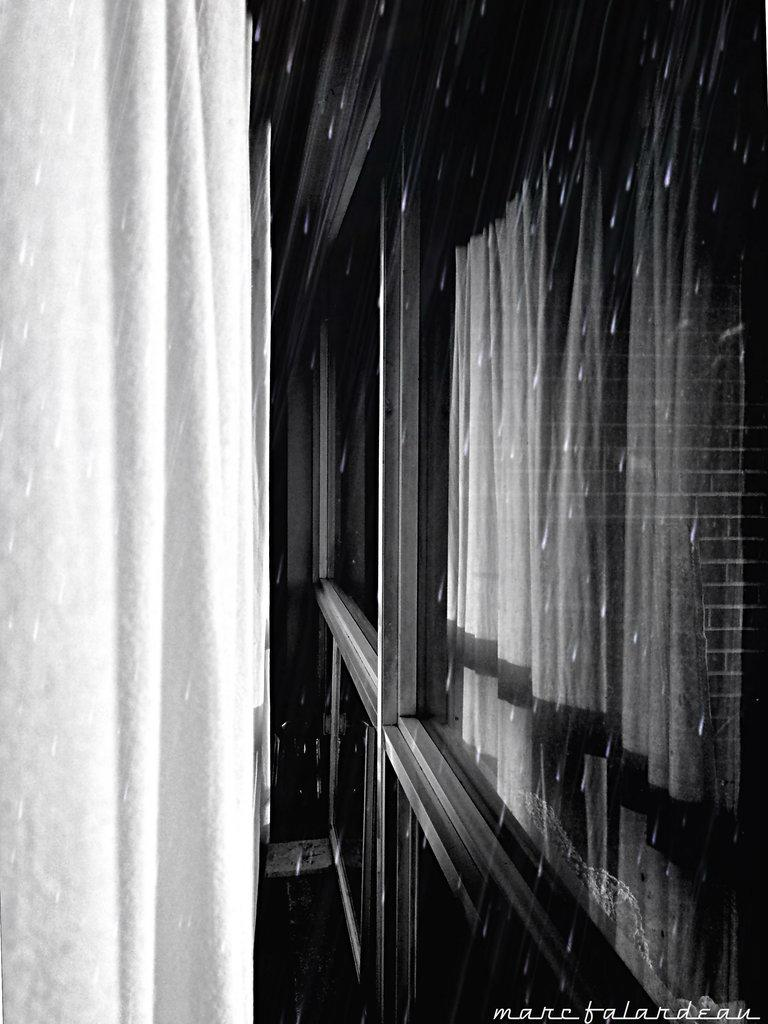What can be seen in the image that allows light to enter a room? There is a window in the image. What material makes up the window? The window has a glass pane. What is inside the window to provide privacy or control light? There is a curtain inside the window. What is happening outside the window in the image? Raindrops are visible outside the window. What type of circle is being used as apparel by the cats in the image? There are no cats or circles present in the image; it features a window with a curtain and raindrops outside. 